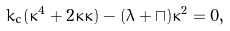<formula> <loc_0><loc_0><loc_500><loc_500>k _ { c } ( \kappa ^ { 4 } + 2 \kappa { \ddot { \kappa } } ) - ( \lambda + \sqcap ) \kappa ^ { 2 } = 0 ,</formula> 